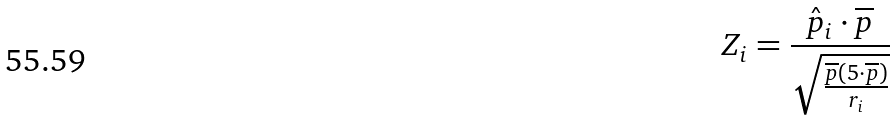<formula> <loc_0><loc_0><loc_500><loc_500>Z _ { i } = \frac { \hat { p } _ { i } \cdot \overline { p } } { \sqrt { \frac { \overline { p } ( 5 \cdot \overline { p } ) } { r _ { i } } } }</formula> 